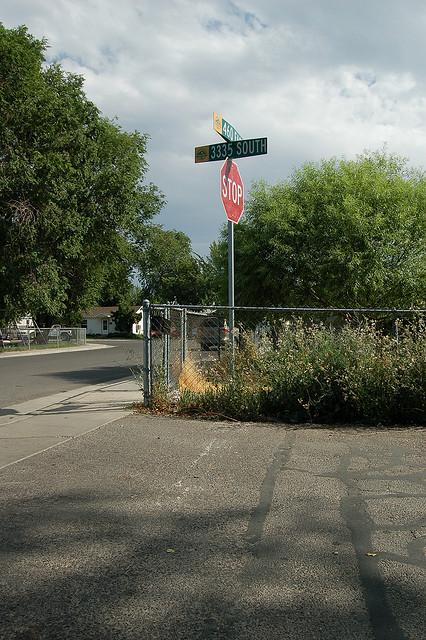What color is the stop sign?
Write a very short answer. Red. Is there a fence near the stop sign?
Give a very brief answer. Yes. Are the cracks in the road filled?
Concise answer only. Yes. 